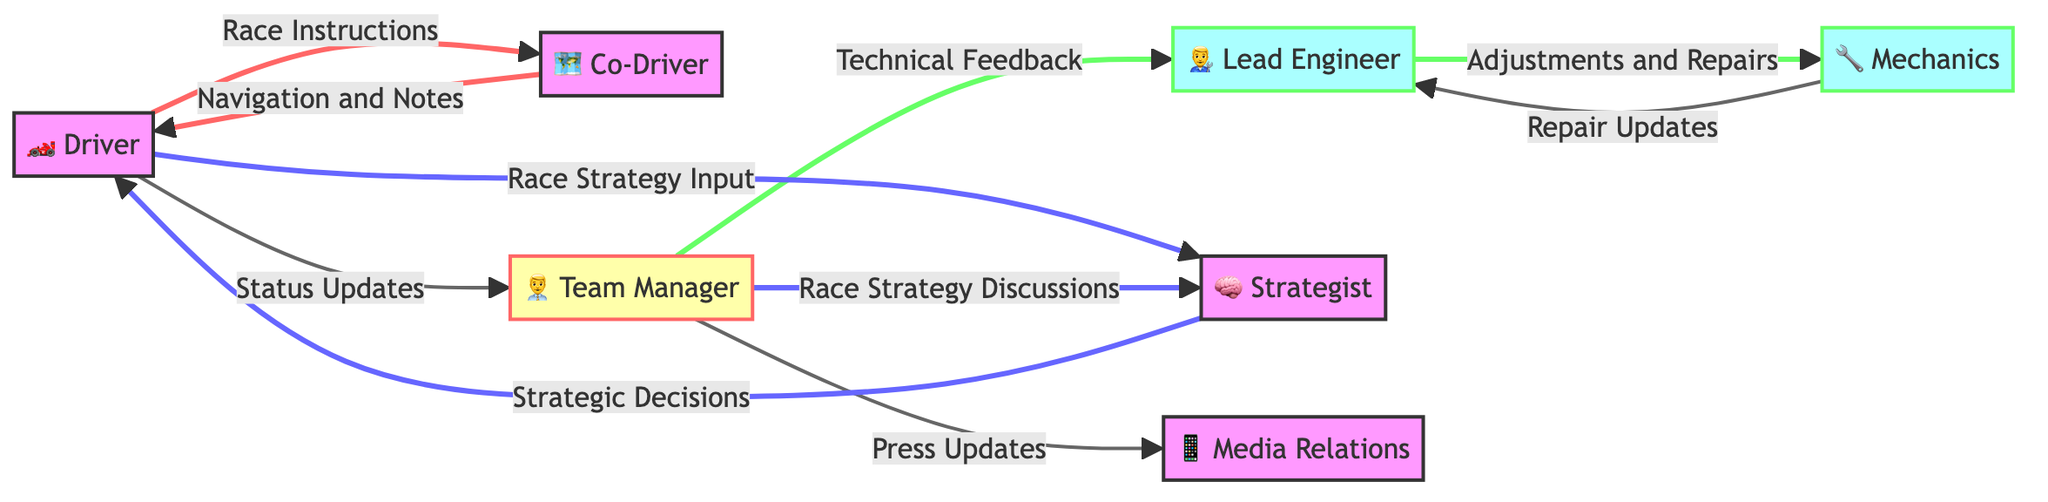What are the nodes in the diagram? The nodes are the entities involved in race team communication: Driver, Co-Driver, Team Manager, Lead Engineer, Mechanics, Strategist, and Media Relations.
Answer: Driver, Co-Driver, Team Manager, Lead Engineer, Mechanics, Strategist, Media Relations How many edges are in the graph? By counting the directional connections (edges) shown in the diagram, there are 10 edges represented.
Answer: 10 Which node does the Team Manager send Technical Feedback to? The Team Manager sends Technical Feedback to the Lead Engineer, as indicated by the directed edge between these two nodes.
Answer: Lead Engineer What type of instructions does the Driver give to the Co-Driver? The Driver gives Race Instructions to the Co-Driver, as denoted by the edge labeled "Race Instructions."
Answer: Race Instructions Who receives Repair Updates from the Mechanics? The Mechanics provide Repair Updates to the Lead Engineer, as shown by the directed edge connecting these nodes.
Answer: Lead Engineer Which node does the Driver receive Strategic Decisions from? The Driver receives Strategic Decisions from the Strategist, as indicated by the directed edge marked "Strategic Decisions."
Answer: Strategist What is the relationship between the Team Manager and Media Relations? The relationship is that the Team Manager provides Press Updates to Media Relations, as depicted in the directed edge labeled "Press Updates."
Answer: Press Updates How many items does the Driver communicate with directly? The Driver communicates with three entities directly: Co-Driver, Team Manager, and Strategist, which are indicated by the three edges originating from the Driver.
Answer: 3 Which two nodes are involved in Race Strategy Discussions? The Team Manager and the Strategist are involved in Race Strategy Discussions, as shown by the directed edge connecting these two nodes.
Answer: Team Manager, Strategist What is the flow direction of communication regarding Navigation and Notes? The communication concerning Navigation and Notes flows from Co-Driver to Driver, as depicted by the directed edge labeled "Navigation and Notes."
Answer: Co-Driver to Driver 